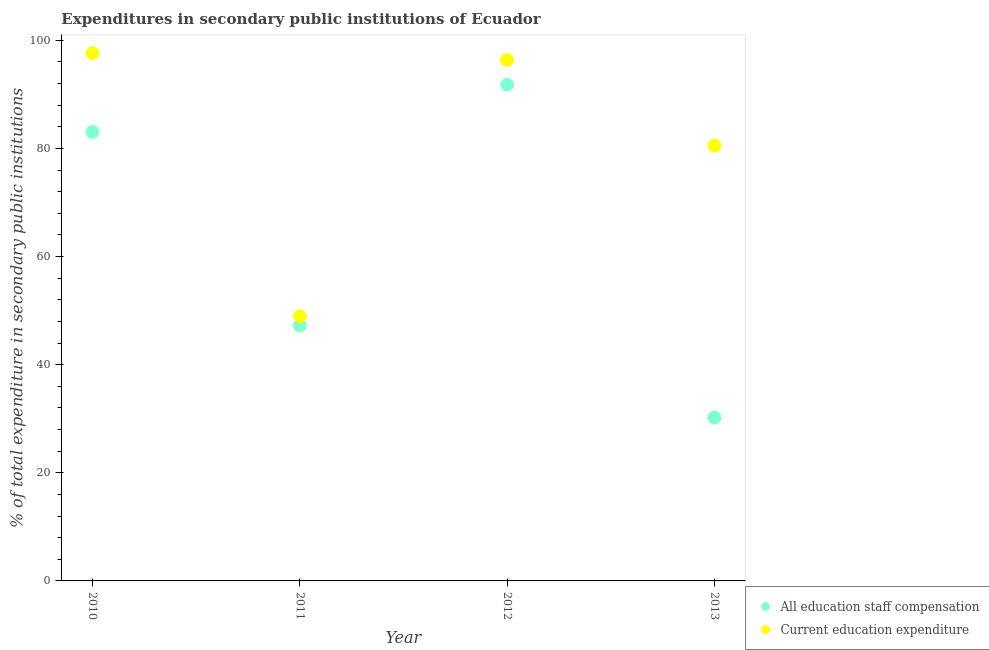How many different coloured dotlines are there?
Offer a very short reply. 2. What is the expenditure in education in 2011?
Ensure brevity in your answer.  48.95. Across all years, what is the maximum expenditure in education?
Make the answer very short. 97.65. Across all years, what is the minimum expenditure in staff compensation?
Provide a short and direct response. 30.24. What is the total expenditure in staff compensation in the graph?
Offer a very short reply. 252.36. What is the difference between the expenditure in education in 2011 and that in 2013?
Your answer should be very brief. -31.59. What is the difference between the expenditure in education in 2013 and the expenditure in staff compensation in 2012?
Your answer should be very brief. -11.27. What is the average expenditure in staff compensation per year?
Provide a succinct answer. 63.09. In the year 2010, what is the difference between the expenditure in education and expenditure in staff compensation?
Ensure brevity in your answer.  14.59. What is the ratio of the expenditure in education in 2010 to that in 2012?
Keep it short and to the point. 1.01. Is the expenditure in staff compensation in 2010 less than that in 2012?
Offer a very short reply. Yes. Is the difference between the expenditure in staff compensation in 2010 and 2012 greater than the difference between the expenditure in education in 2010 and 2012?
Provide a succinct answer. No. What is the difference between the highest and the second highest expenditure in staff compensation?
Provide a succinct answer. 8.76. What is the difference between the highest and the lowest expenditure in education?
Your answer should be very brief. 48.7. In how many years, is the expenditure in staff compensation greater than the average expenditure in staff compensation taken over all years?
Provide a short and direct response. 2. Is the sum of the expenditure in staff compensation in 2011 and 2012 greater than the maximum expenditure in education across all years?
Make the answer very short. Yes. Is the expenditure in education strictly greater than the expenditure in staff compensation over the years?
Ensure brevity in your answer.  Yes. Is the expenditure in staff compensation strictly less than the expenditure in education over the years?
Give a very brief answer. Yes. How many dotlines are there?
Make the answer very short. 2. How many years are there in the graph?
Your answer should be very brief. 4. What is the difference between two consecutive major ticks on the Y-axis?
Offer a terse response. 20. Are the values on the major ticks of Y-axis written in scientific E-notation?
Offer a terse response. No. Does the graph contain any zero values?
Provide a succinct answer. No. Does the graph contain grids?
Your answer should be very brief. No. Where does the legend appear in the graph?
Offer a terse response. Bottom right. How many legend labels are there?
Provide a succinct answer. 2. What is the title of the graph?
Provide a short and direct response. Expenditures in secondary public institutions of Ecuador. Does "Under-five" appear as one of the legend labels in the graph?
Offer a terse response. No. What is the label or title of the X-axis?
Make the answer very short. Year. What is the label or title of the Y-axis?
Ensure brevity in your answer.  % of total expenditure in secondary public institutions. What is the % of total expenditure in secondary public institutions of All education staff compensation in 2010?
Keep it short and to the point. 83.05. What is the % of total expenditure in secondary public institutions of Current education expenditure in 2010?
Ensure brevity in your answer.  97.65. What is the % of total expenditure in secondary public institutions of All education staff compensation in 2011?
Your response must be concise. 47.26. What is the % of total expenditure in secondary public institutions of Current education expenditure in 2011?
Offer a very short reply. 48.95. What is the % of total expenditure in secondary public institutions of All education staff compensation in 2012?
Make the answer very short. 91.81. What is the % of total expenditure in secondary public institutions of Current education expenditure in 2012?
Offer a very short reply. 96.4. What is the % of total expenditure in secondary public institutions of All education staff compensation in 2013?
Give a very brief answer. 30.24. What is the % of total expenditure in secondary public institutions of Current education expenditure in 2013?
Keep it short and to the point. 80.54. Across all years, what is the maximum % of total expenditure in secondary public institutions in All education staff compensation?
Give a very brief answer. 91.81. Across all years, what is the maximum % of total expenditure in secondary public institutions of Current education expenditure?
Ensure brevity in your answer.  97.65. Across all years, what is the minimum % of total expenditure in secondary public institutions in All education staff compensation?
Offer a terse response. 30.24. Across all years, what is the minimum % of total expenditure in secondary public institutions in Current education expenditure?
Provide a short and direct response. 48.95. What is the total % of total expenditure in secondary public institutions of All education staff compensation in the graph?
Your answer should be very brief. 252.36. What is the total % of total expenditure in secondary public institutions in Current education expenditure in the graph?
Make the answer very short. 323.53. What is the difference between the % of total expenditure in secondary public institutions of All education staff compensation in 2010 and that in 2011?
Give a very brief answer. 35.8. What is the difference between the % of total expenditure in secondary public institutions of Current education expenditure in 2010 and that in 2011?
Keep it short and to the point. 48.7. What is the difference between the % of total expenditure in secondary public institutions in All education staff compensation in 2010 and that in 2012?
Keep it short and to the point. -8.76. What is the difference between the % of total expenditure in secondary public institutions of Current education expenditure in 2010 and that in 2012?
Offer a terse response. 1.25. What is the difference between the % of total expenditure in secondary public institutions in All education staff compensation in 2010 and that in 2013?
Provide a short and direct response. 52.81. What is the difference between the % of total expenditure in secondary public institutions of Current education expenditure in 2010 and that in 2013?
Offer a terse response. 17.11. What is the difference between the % of total expenditure in secondary public institutions of All education staff compensation in 2011 and that in 2012?
Offer a very short reply. -44.56. What is the difference between the % of total expenditure in secondary public institutions of Current education expenditure in 2011 and that in 2012?
Your answer should be compact. -47.45. What is the difference between the % of total expenditure in secondary public institutions of All education staff compensation in 2011 and that in 2013?
Offer a terse response. 17.02. What is the difference between the % of total expenditure in secondary public institutions of Current education expenditure in 2011 and that in 2013?
Provide a succinct answer. -31.59. What is the difference between the % of total expenditure in secondary public institutions in All education staff compensation in 2012 and that in 2013?
Keep it short and to the point. 61.58. What is the difference between the % of total expenditure in secondary public institutions of Current education expenditure in 2012 and that in 2013?
Keep it short and to the point. 15.86. What is the difference between the % of total expenditure in secondary public institutions of All education staff compensation in 2010 and the % of total expenditure in secondary public institutions of Current education expenditure in 2011?
Offer a terse response. 34.1. What is the difference between the % of total expenditure in secondary public institutions of All education staff compensation in 2010 and the % of total expenditure in secondary public institutions of Current education expenditure in 2012?
Make the answer very short. -13.35. What is the difference between the % of total expenditure in secondary public institutions in All education staff compensation in 2010 and the % of total expenditure in secondary public institutions in Current education expenditure in 2013?
Give a very brief answer. 2.51. What is the difference between the % of total expenditure in secondary public institutions of All education staff compensation in 2011 and the % of total expenditure in secondary public institutions of Current education expenditure in 2012?
Ensure brevity in your answer.  -49.14. What is the difference between the % of total expenditure in secondary public institutions of All education staff compensation in 2011 and the % of total expenditure in secondary public institutions of Current education expenditure in 2013?
Give a very brief answer. -33.28. What is the difference between the % of total expenditure in secondary public institutions in All education staff compensation in 2012 and the % of total expenditure in secondary public institutions in Current education expenditure in 2013?
Make the answer very short. 11.27. What is the average % of total expenditure in secondary public institutions of All education staff compensation per year?
Offer a terse response. 63.09. What is the average % of total expenditure in secondary public institutions of Current education expenditure per year?
Your answer should be very brief. 80.88. In the year 2010, what is the difference between the % of total expenditure in secondary public institutions of All education staff compensation and % of total expenditure in secondary public institutions of Current education expenditure?
Keep it short and to the point. -14.59. In the year 2011, what is the difference between the % of total expenditure in secondary public institutions in All education staff compensation and % of total expenditure in secondary public institutions in Current education expenditure?
Your response must be concise. -1.69. In the year 2012, what is the difference between the % of total expenditure in secondary public institutions in All education staff compensation and % of total expenditure in secondary public institutions in Current education expenditure?
Provide a succinct answer. -4.58. In the year 2013, what is the difference between the % of total expenditure in secondary public institutions of All education staff compensation and % of total expenditure in secondary public institutions of Current education expenditure?
Give a very brief answer. -50.3. What is the ratio of the % of total expenditure in secondary public institutions of All education staff compensation in 2010 to that in 2011?
Make the answer very short. 1.76. What is the ratio of the % of total expenditure in secondary public institutions of Current education expenditure in 2010 to that in 2011?
Your answer should be very brief. 1.99. What is the ratio of the % of total expenditure in secondary public institutions in All education staff compensation in 2010 to that in 2012?
Ensure brevity in your answer.  0.9. What is the ratio of the % of total expenditure in secondary public institutions in All education staff compensation in 2010 to that in 2013?
Make the answer very short. 2.75. What is the ratio of the % of total expenditure in secondary public institutions of Current education expenditure in 2010 to that in 2013?
Your response must be concise. 1.21. What is the ratio of the % of total expenditure in secondary public institutions in All education staff compensation in 2011 to that in 2012?
Provide a succinct answer. 0.51. What is the ratio of the % of total expenditure in secondary public institutions of Current education expenditure in 2011 to that in 2012?
Offer a terse response. 0.51. What is the ratio of the % of total expenditure in secondary public institutions of All education staff compensation in 2011 to that in 2013?
Provide a short and direct response. 1.56. What is the ratio of the % of total expenditure in secondary public institutions in Current education expenditure in 2011 to that in 2013?
Offer a very short reply. 0.61. What is the ratio of the % of total expenditure in secondary public institutions in All education staff compensation in 2012 to that in 2013?
Provide a succinct answer. 3.04. What is the ratio of the % of total expenditure in secondary public institutions in Current education expenditure in 2012 to that in 2013?
Ensure brevity in your answer.  1.2. What is the difference between the highest and the second highest % of total expenditure in secondary public institutions in All education staff compensation?
Provide a succinct answer. 8.76. What is the difference between the highest and the second highest % of total expenditure in secondary public institutions in Current education expenditure?
Provide a succinct answer. 1.25. What is the difference between the highest and the lowest % of total expenditure in secondary public institutions of All education staff compensation?
Give a very brief answer. 61.58. What is the difference between the highest and the lowest % of total expenditure in secondary public institutions of Current education expenditure?
Make the answer very short. 48.7. 